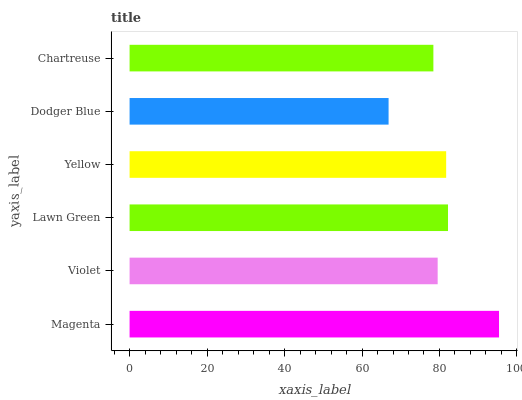Is Dodger Blue the minimum?
Answer yes or no. Yes. Is Magenta the maximum?
Answer yes or no. Yes. Is Violet the minimum?
Answer yes or no. No. Is Violet the maximum?
Answer yes or no. No. Is Magenta greater than Violet?
Answer yes or no. Yes. Is Violet less than Magenta?
Answer yes or no. Yes. Is Violet greater than Magenta?
Answer yes or no. No. Is Magenta less than Violet?
Answer yes or no. No. Is Yellow the high median?
Answer yes or no. Yes. Is Violet the low median?
Answer yes or no. Yes. Is Chartreuse the high median?
Answer yes or no. No. Is Dodger Blue the low median?
Answer yes or no. No. 